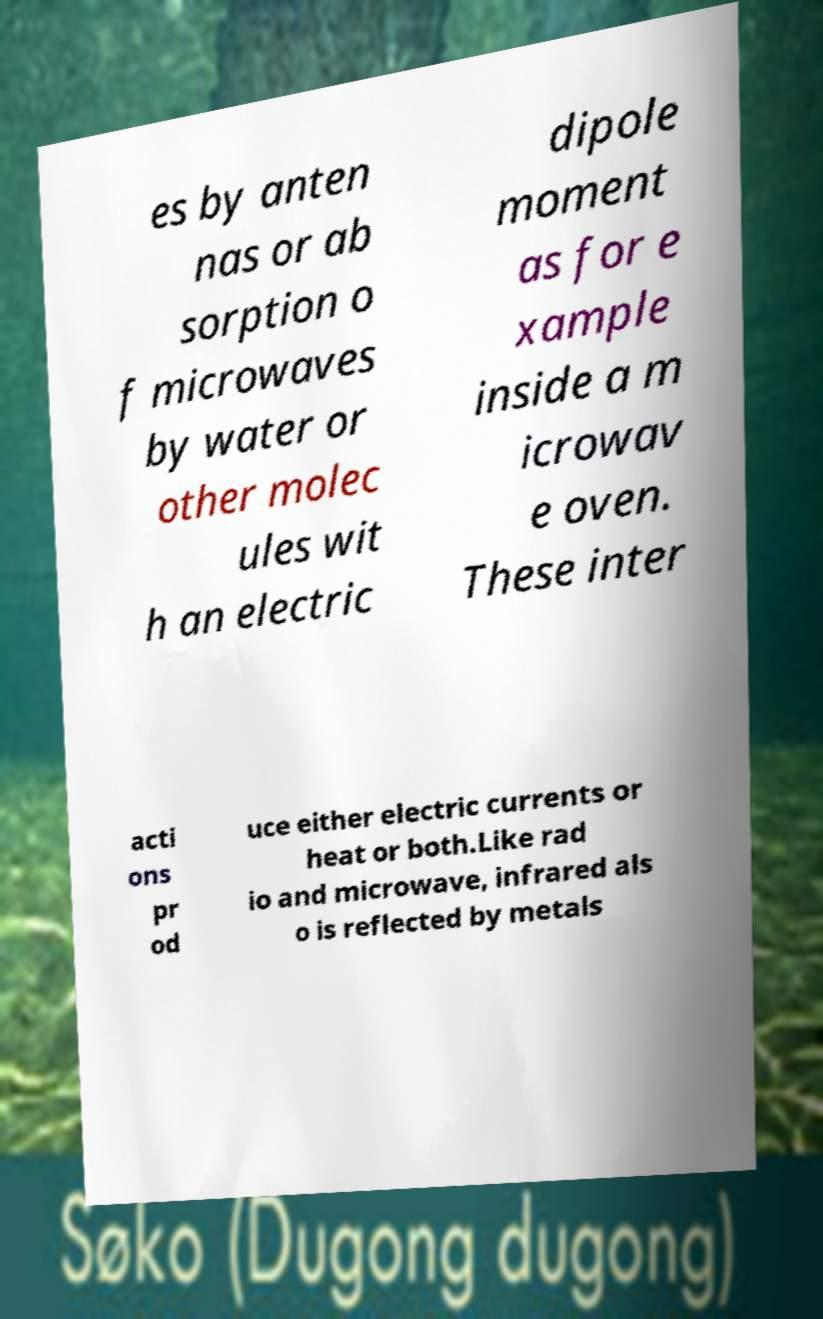I need the written content from this picture converted into text. Can you do that? es by anten nas or ab sorption o f microwaves by water or other molec ules wit h an electric dipole moment as for e xample inside a m icrowav e oven. These inter acti ons pr od uce either electric currents or heat or both.Like rad io and microwave, infrared als o is reflected by metals 